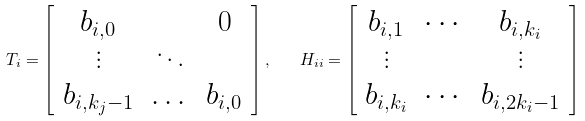<formula> <loc_0><loc_0><loc_500><loc_500>T _ { i } = \left [ \begin{array} { c c c } b _ { i , 0 } & & 0 \\ \vdots & \ddots & \\ b _ { i , k _ { j } - 1 } & \dots & b _ { i , 0 } \end{array} \right ] , \quad H _ { i i } = \left [ \begin{array} { c c c } b _ { i , 1 } & \cdots & b _ { i , k _ { i } } \\ \vdots & & \vdots \\ b _ { i , k _ { i } } & \cdots & b _ { i , 2 k _ { i } - 1 } \end{array} \right ]</formula> 